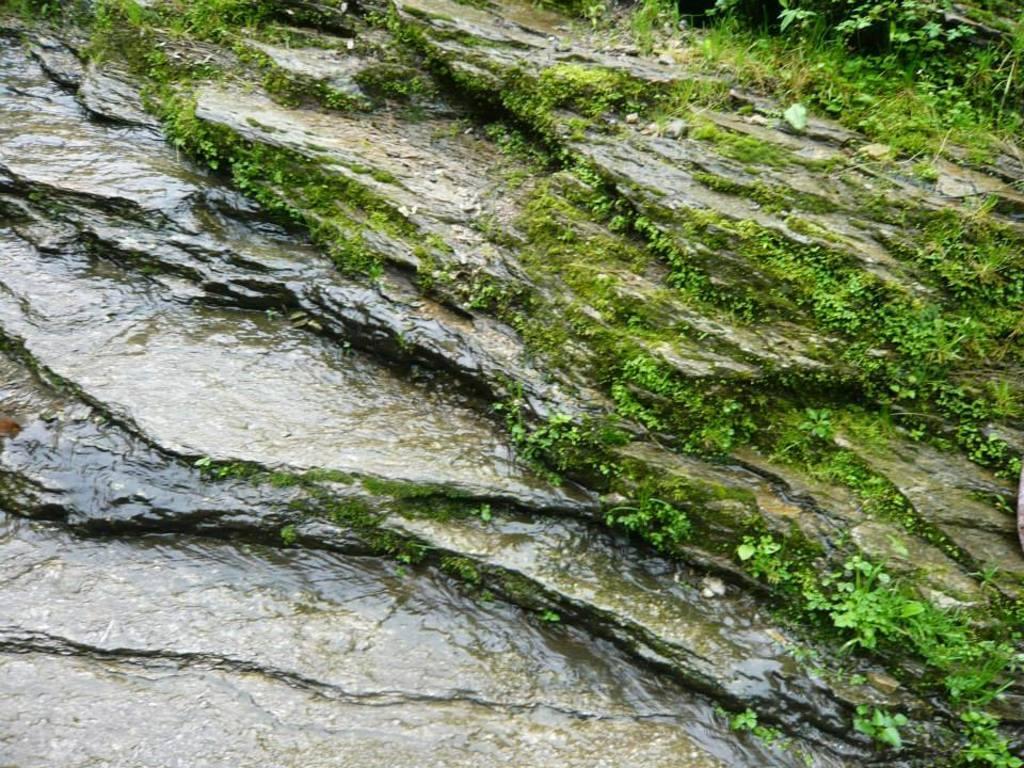How would you summarize this image in a sentence or two? In this image there is a rock with water at the bottom. There are small plants and green grass in the right corner. 